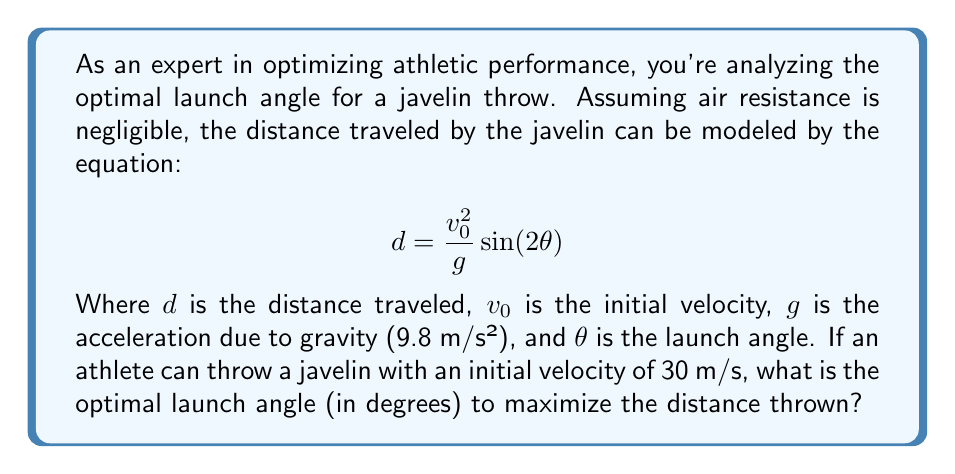Can you answer this question? To find the optimal launch angle, we need to maximize the distance function:

1) First, we recognize that $\frac{v_0^2}{g}$ is constant for a given throw. Let's call this constant $k$. So our function becomes:

   $$d = k \sin(2\theta)$$

2) To find the maximum of this function, we need to find where its derivative equals zero:

   $$\frac{d}{d\theta}(k \sin(2\theta)) = 2k \cos(2\theta) = 0$$

3) Solving this equation:

   $$2k \cos(2\theta) = 0$$
   $$\cos(2\theta) = 0$$

4) The cosine function equals zero when its argument is 90° or 270°. Since we're dealing with a launch angle, we're interested in the positive solution:

   $$2\theta = 90°$$
   $$\theta = 45°$$

5) To confirm this is a maximum (not a minimum), we can check the second derivative:

   $$\frac{d^2}{d\theta^2}(k \sin(2\theta)) = -4k \sin(2\theta)$$

   At $\theta = 45°$, this is negative, confirming a maximum.

Therefore, the optimal launch angle to maximize distance is 45°.
Answer: 45° 